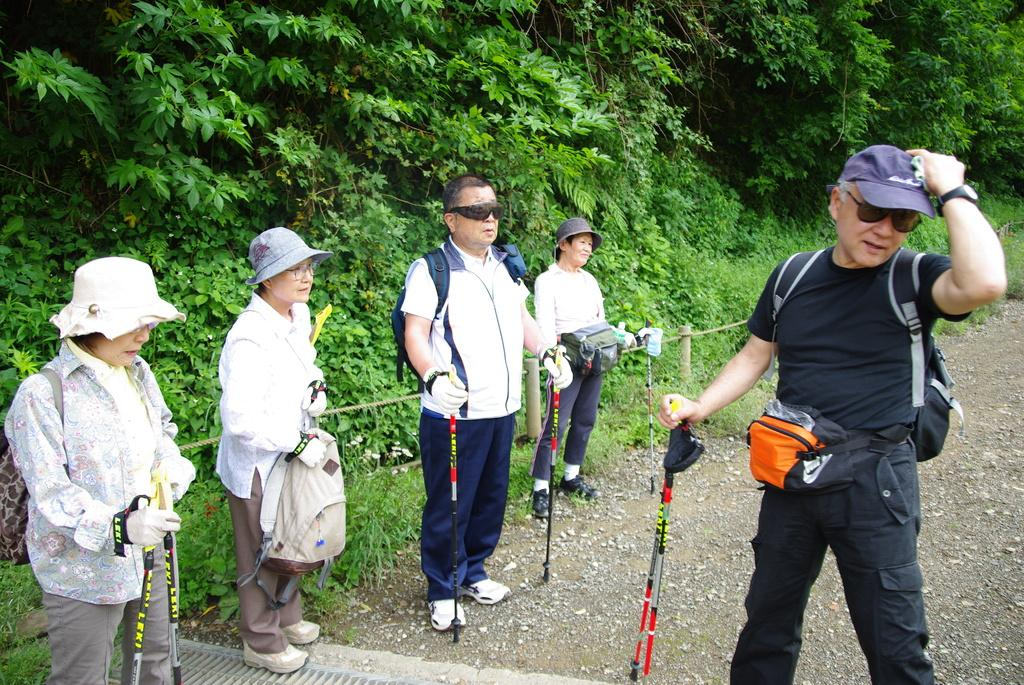How many people are in the image? There are five persons in the image. What are the persons doing in the image? The persons are standing on the ground and holding sticks in their hands. What can be seen in the background of the image? There is grass and trees in the background of the image. When was the image taken? The image was taken during the day. What type of yam is being prepared by the persons in the image? There is no yam present in the image, and the persons are holding sticks, not preparing food. 